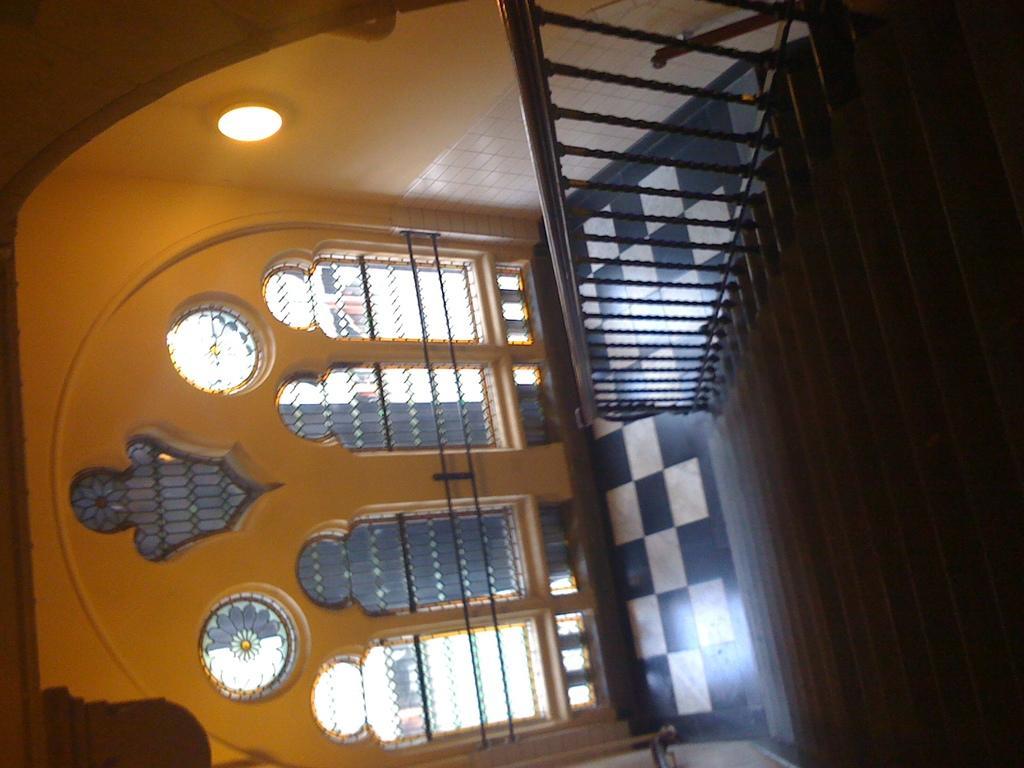In one or two sentences, can you explain what this image depicts? Here in this picture we can see a staircase present and in front of that we can see windows on the wall over there. 